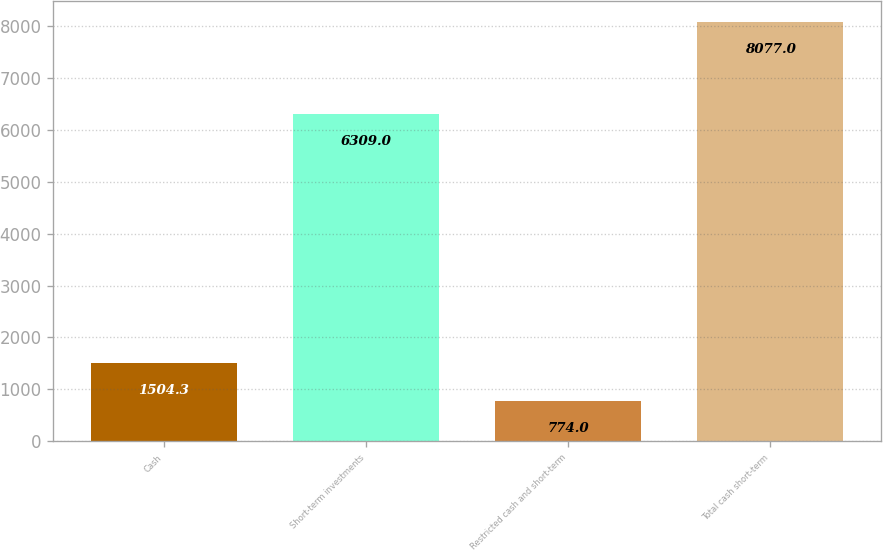<chart> <loc_0><loc_0><loc_500><loc_500><bar_chart><fcel>Cash<fcel>Short-term investments<fcel>Restricted cash and short-term<fcel>Total cash short-term<nl><fcel>1504.3<fcel>6309<fcel>774<fcel>8077<nl></chart> 